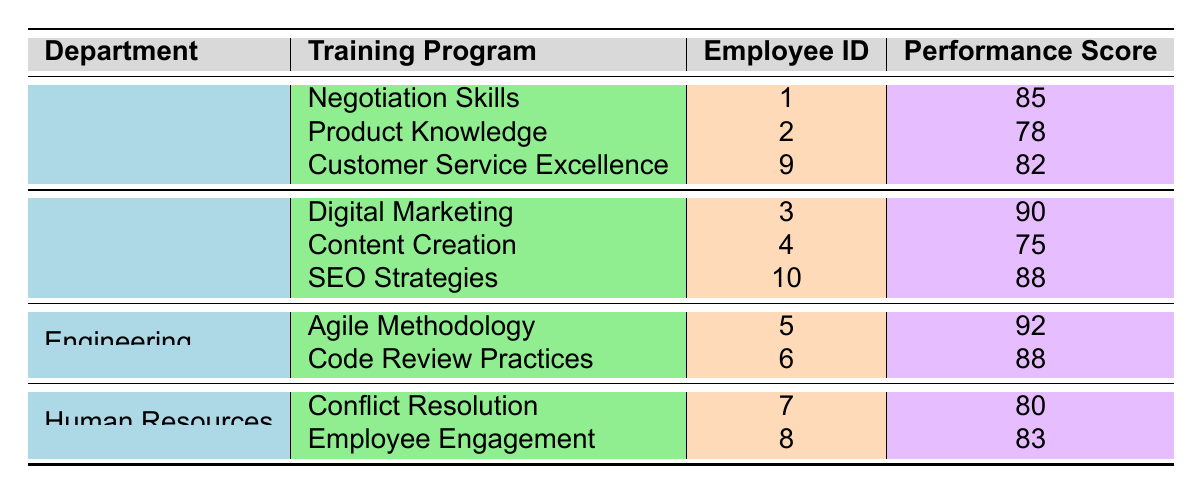What is the highest Performance Score among the employees in the Engineering department? The table shows two employees in the Engineering department with Performance Scores of 92 and 88. The highest score among these is 92.
Answer: 92 Which Training Program did the employee with Employee ID 4 participate in? Looking at the table, Employee ID 4 is associated with the Marketing department and participated in the Content Creation training program.
Answer: Content Creation Is there any employee in the Sales department with a Performance Score above 80? According to the table, the Performance Scores for Sales employees are 85, 78, and 82. Since 85 and 82 are both above 80, the answer is yes.
Answer: Yes What is the average Performance Score for employees who took the Digital Marketing training program? There is one employee who took the Digital Marketing training program with a Performance Score of 90. Therefore, the average score is 90/1, which remains 90.
Answer: 90 Which department has the lowest average Performance Score based on the available data? The Performance Scores for each department are as follows: Sales (85, 78, 82) average is 81.67; Marketing (90, 75, 88) average is 84.33; Engineering (92, 88) average is 90; Human Resources (80, 83) average is 81.5. The Department with the lowest average Performance Score is Sales with an average of 81.67.
Answer: Sales How many employees from the Human Resources department scored below 85? The Performance Scores for Human Resources employees are 80 and 83. Both of these scores are below 85, therefore, there are two employees who scored below that threshold.
Answer: 2 